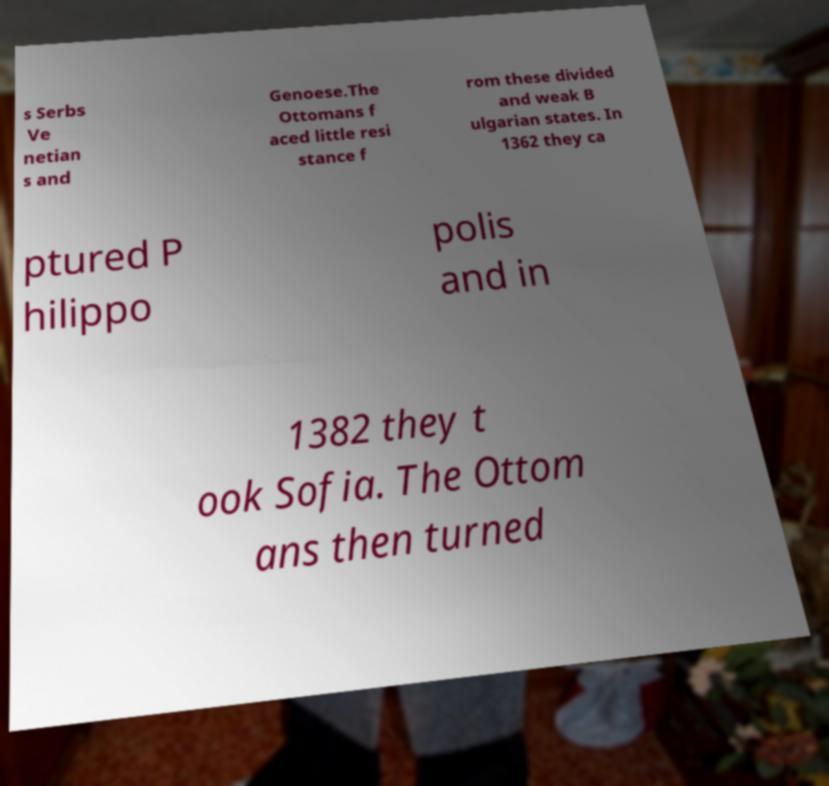What messages or text are displayed in this image? I need them in a readable, typed format. s Serbs Ve netian s and Genoese.The Ottomans f aced little resi stance f rom these divided and weak B ulgarian states. In 1362 they ca ptured P hilippo polis and in 1382 they t ook Sofia. The Ottom ans then turned 